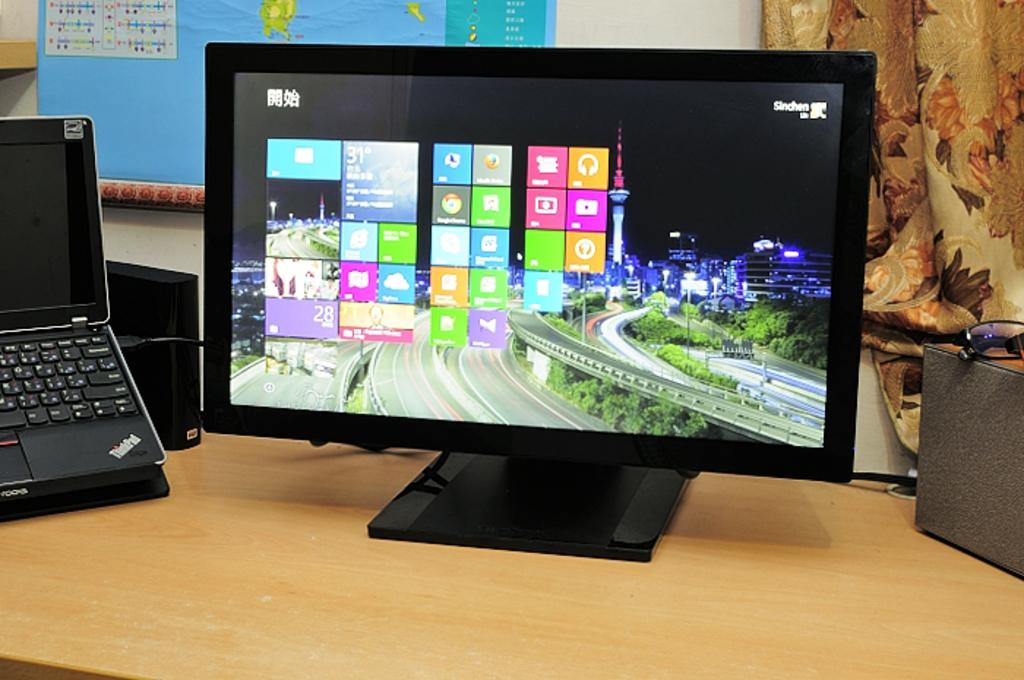<image>
Give a short and clear explanation of the subsequent image. Th Windows background on this monitor features the city of Sinchen. 